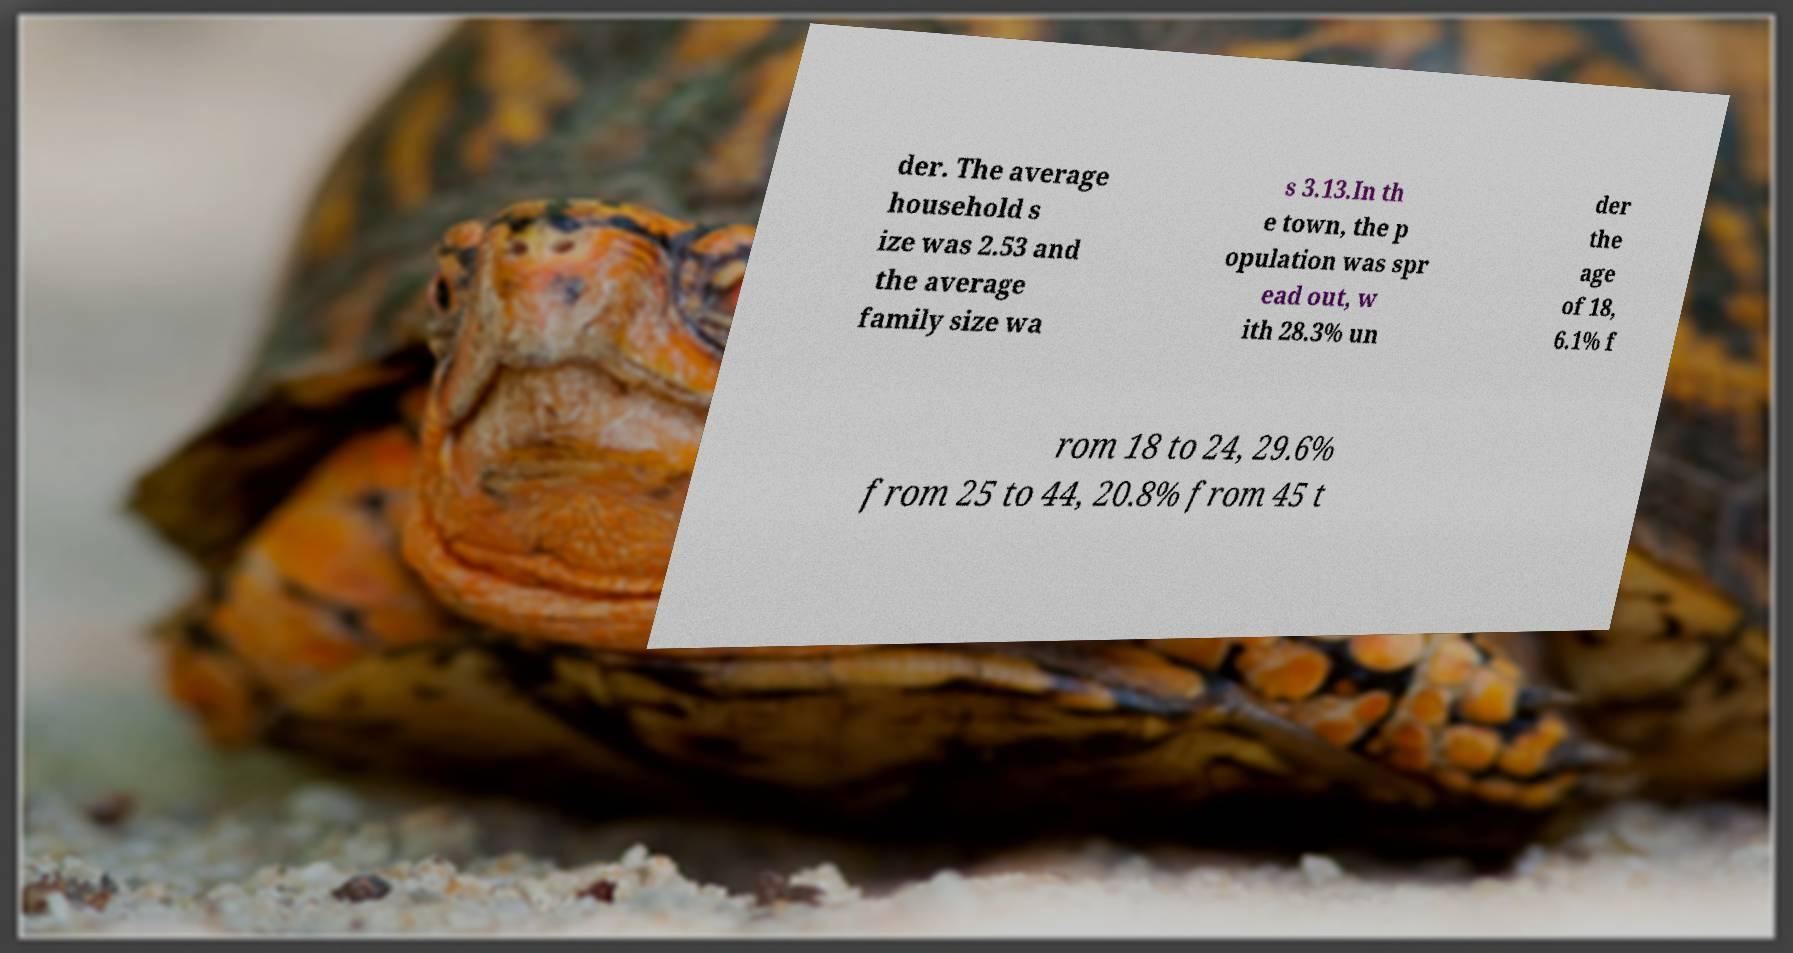I need the written content from this picture converted into text. Can you do that? der. The average household s ize was 2.53 and the average family size wa s 3.13.In th e town, the p opulation was spr ead out, w ith 28.3% un der the age of 18, 6.1% f rom 18 to 24, 29.6% from 25 to 44, 20.8% from 45 t 